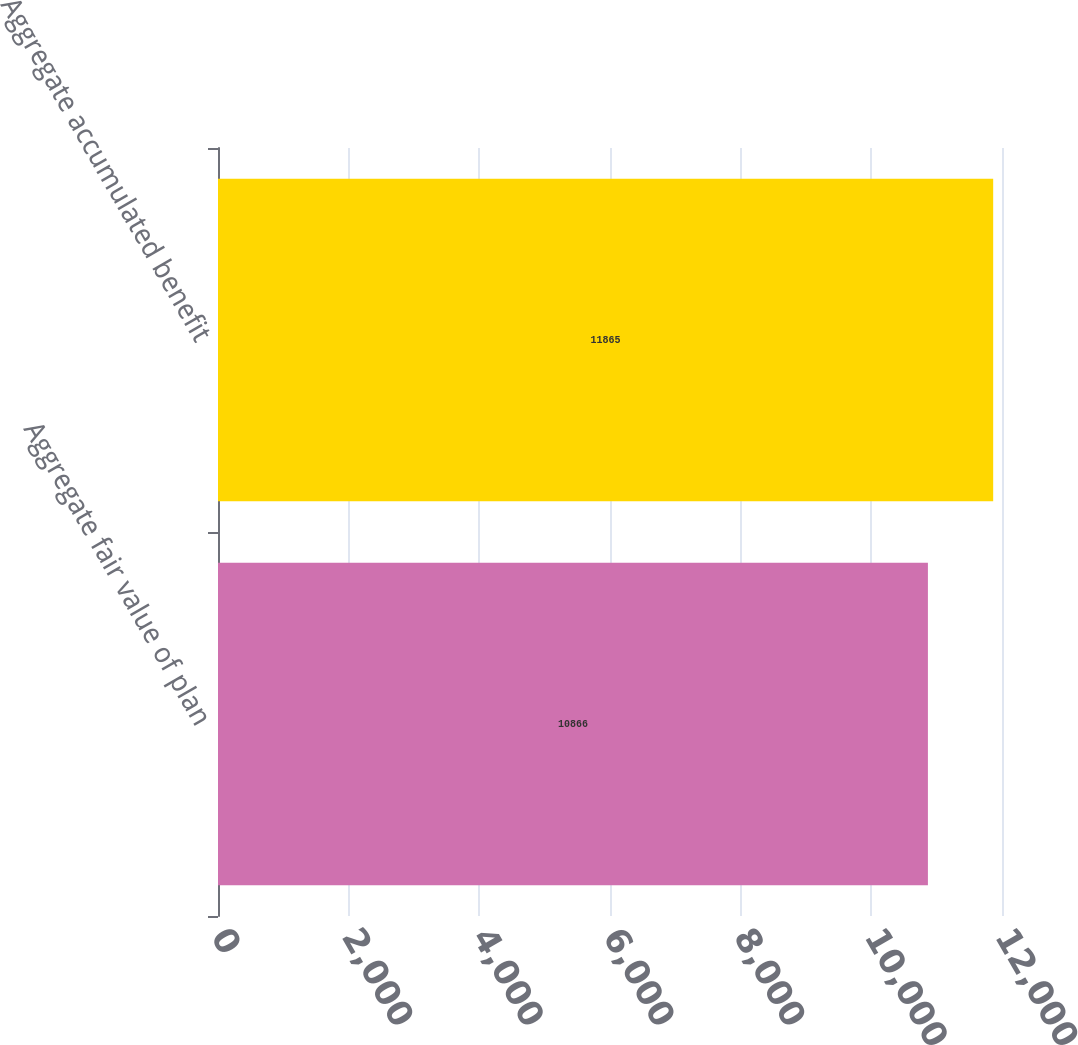Convert chart to OTSL. <chart><loc_0><loc_0><loc_500><loc_500><bar_chart><fcel>Aggregate fair value of plan<fcel>Aggregate accumulated benefit<nl><fcel>10866<fcel>11865<nl></chart> 